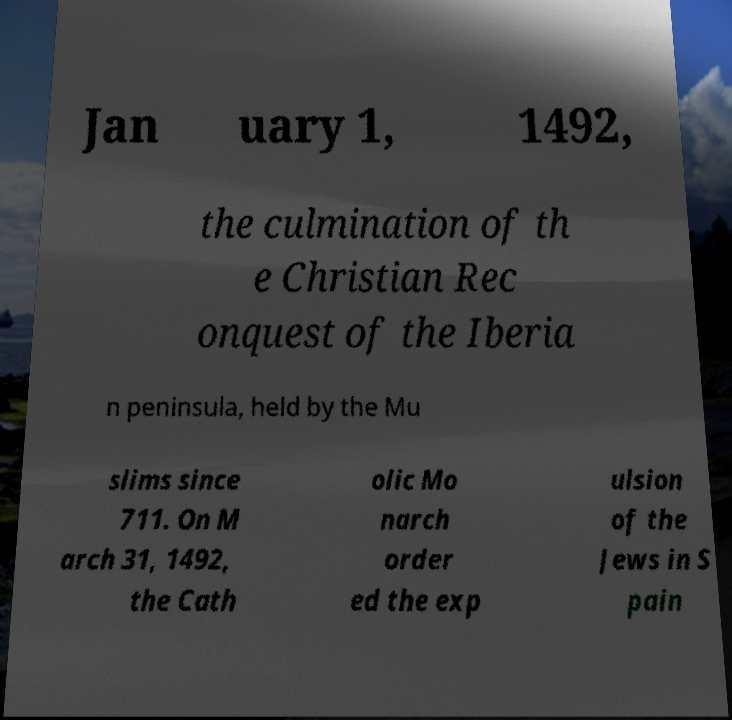What messages or text are displayed in this image? I need them in a readable, typed format. Jan uary 1, 1492, the culmination of th e Christian Rec onquest of the Iberia n peninsula, held by the Mu slims since 711. On M arch 31, 1492, the Cath olic Mo narch order ed the exp ulsion of the Jews in S pain 